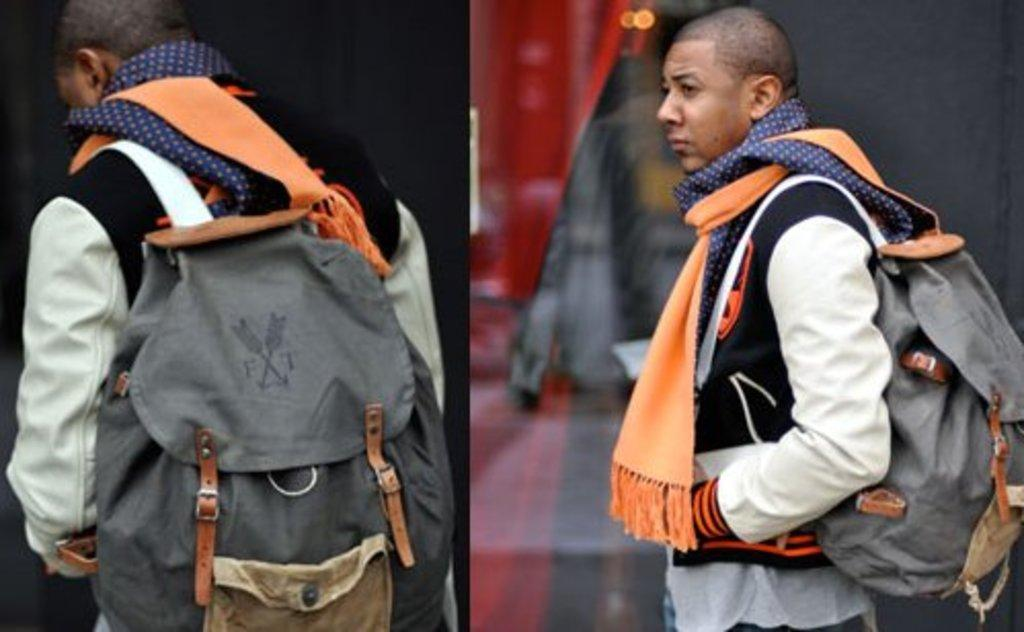<image>
Describe the image concisely. A man wearing a grey backpack that says FT on it. 